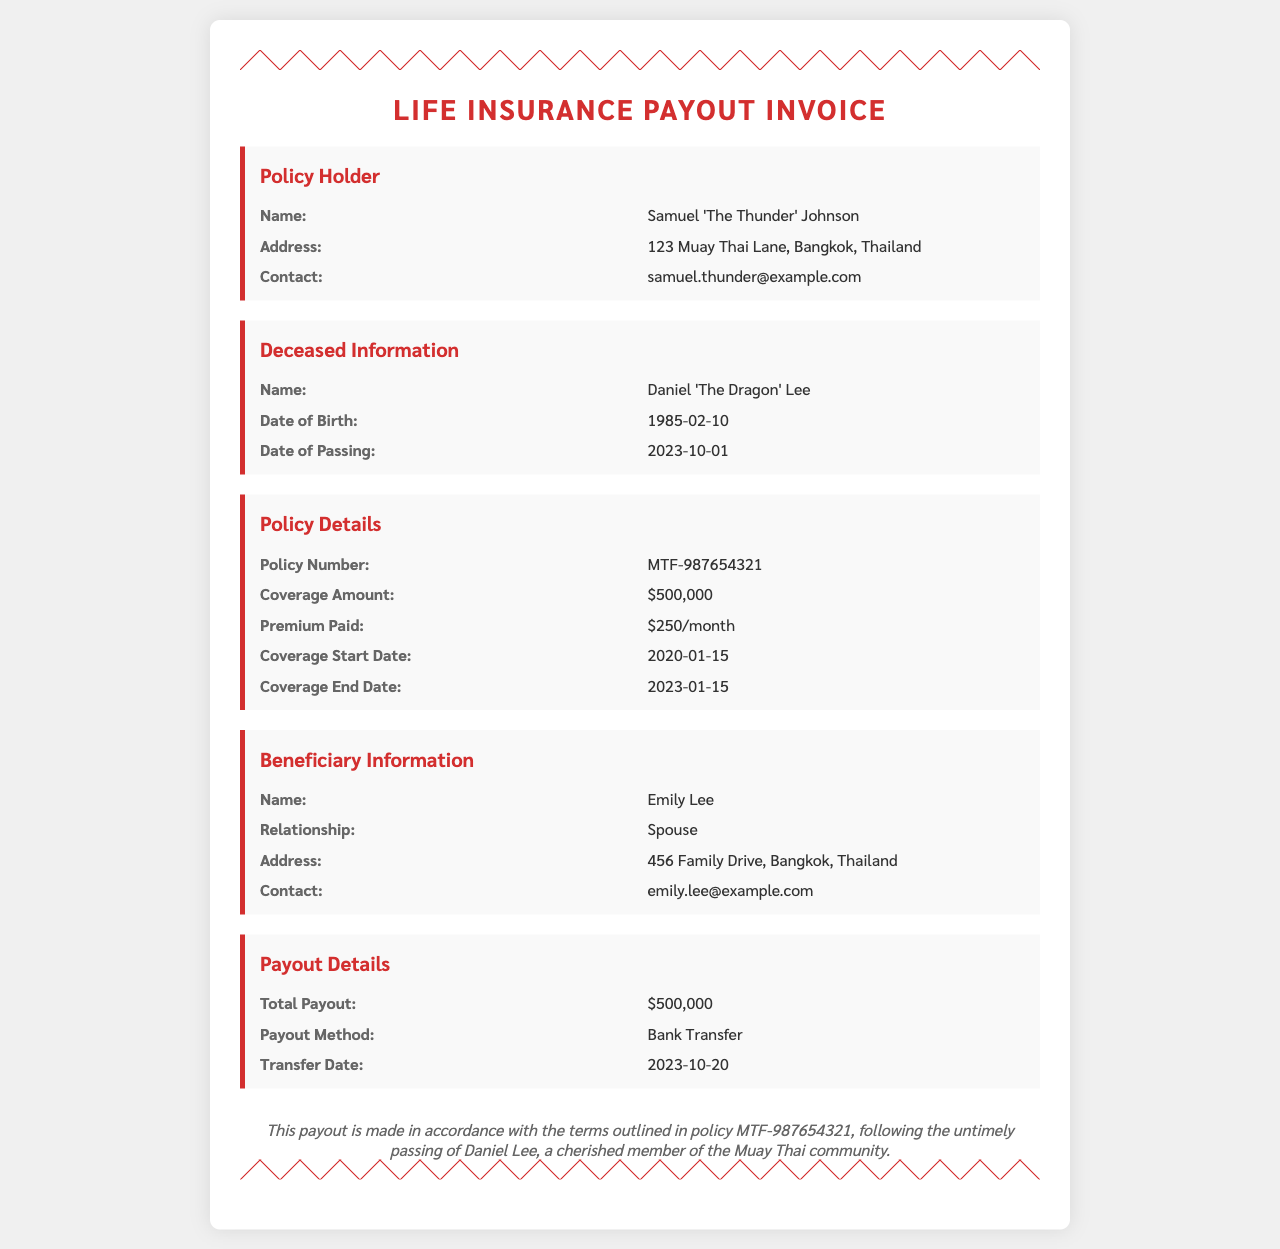What is the policy number? The policy number is listed under the Policy Details section, which can be found as MTF-987654321.
Answer: MTF-987654321 Who is the beneficiary? The beneficiary information provides the name of the person entitled to the payout, which is noted as Emily Lee.
Answer: Emily Lee What is the coverage amount? The coverage amount can be found in the Policy Details section and is stated as $500,000.
Answer: $500,000 When did Daniel 'The Dragon' Lee pass away? The date of passing for Daniel Lee is provided in the Deceased Information section as 2023-10-01.
Answer: 2023-10-01 What relationship does the beneficiary have to the deceased? The relationship between Emily Lee and Daniel Lee is specified in the Beneficiary Information section as Spouse.
Answer: Spouse What is the total payout amount? The total payout amount is mentioned in the Payout Details section, which is $500,000.
Answer: $500,000 When is the transfer date for the payout? The transfer date for the payout is given in the Payout Details section as 2023-10-20.
Answer: 2023-10-20 What is the premium paid? The premium paid is indicated in the Policy Details section, which states $250/month.
Answer: $250/month What is the coverage start date? The start date of the coverage can be found in the Policy Details section, which is 2020-01-15.
Answer: 2020-01-15 What city does the policy holder live in? The address of the policy holder specifies the city as Bangkok, provided in the Policy Holder section.
Answer: Bangkok 